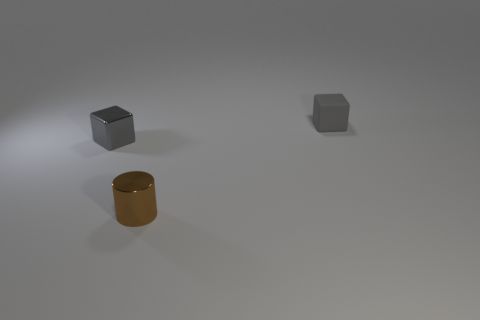What is the material of the other small object that is the same color as the matte object?
Offer a terse response. Metal. There is a gray cube that is on the left side of the small matte thing; is it the same size as the gray cube that is right of the brown metal thing?
Give a very brief answer. Yes. There is a gray block on the right side of the gray cube that is on the left side of the small brown shiny cylinder; what size is it?
Offer a very short reply. Small. There is a object that is behind the cylinder and in front of the small gray rubber block; what is its material?
Offer a terse response. Metal. The tiny metal cube has what color?
Your answer should be compact. Gray. Is there anything else that is the same material as the brown cylinder?
Your response must be concise. Yes. What shape is the small object left of the cylinder?
Keep it short and to the point. Cube. There is a block to the left of the block that is on the right side of the small gray shiny block; is there a cube in front of it?
Your answer should be very brief. No. Is there anything else that has the same shape as the gray rubber object?
Make the answer very short. Yes. Are any tiny brown shiny objects visible?
Your answer should be compact. Yes. 